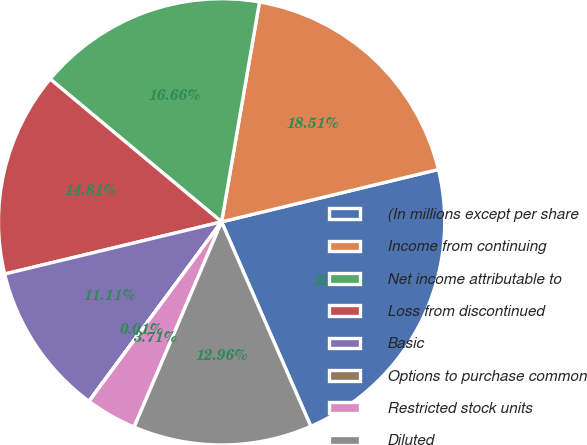Convert chart. <chart><loc_0><loc_0><loc_500><loc_500><pie_chart><fcel>(In millions except per share<fcel>Income from continuing<fcel>Net income attributable to<fcel>Loss from discontinued<fcel>Basic<fcel>Options to purchase common<fcel>Restricted stock units<fcel>Diluted<nl><fcel>22.22%<fcel>18.51%<fcel>16.66%<fcel>14.81%<fcel>11.11%<fcel>0.01%<fcel>3.71%<fcel>12.96%<nl></chart> 